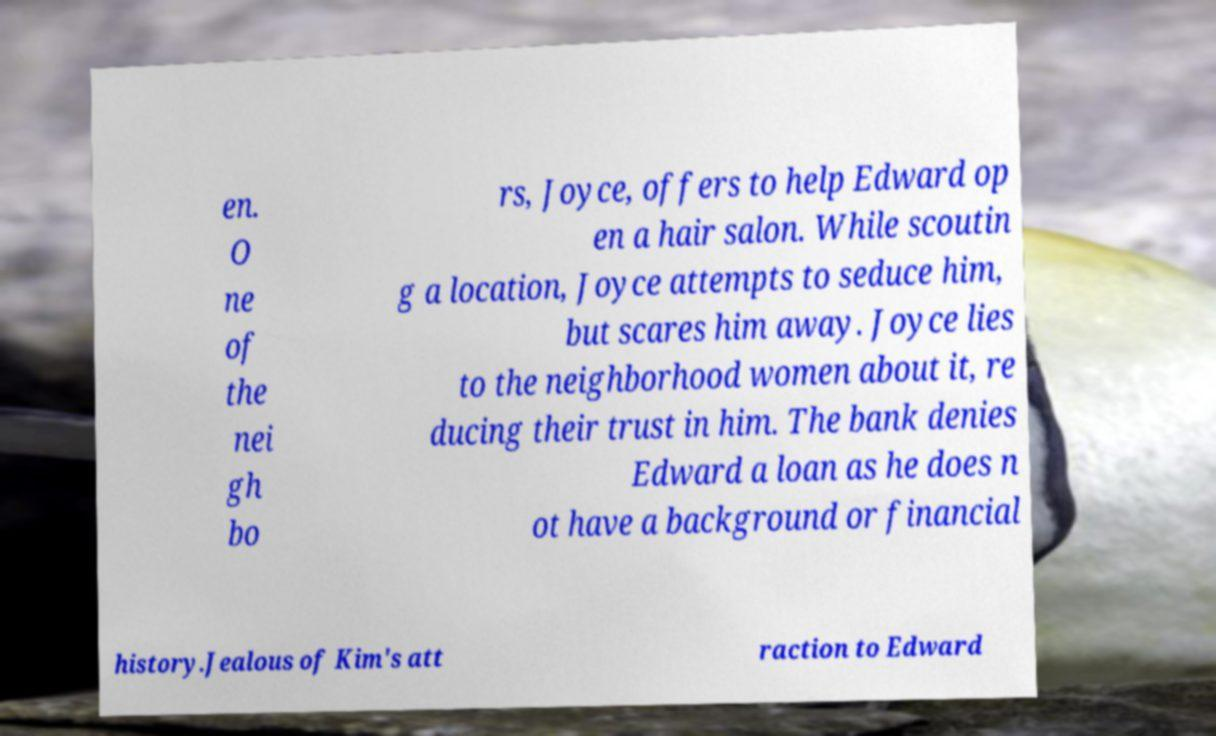Can you accurately transcribe the text from the provided image for me? en. O ne of the nei gh bo rs, Joyce, offers to help Edward op en a hair salon. While scoutin g a location, Joyce attempts to seduce him, but scares him away. Joyce lies to the neighborhood women about it, re ducing their trust in him. The bank denies Edward a loan as he does n ot have a background or financial history.Jealous of Kim's att raction to Edward 